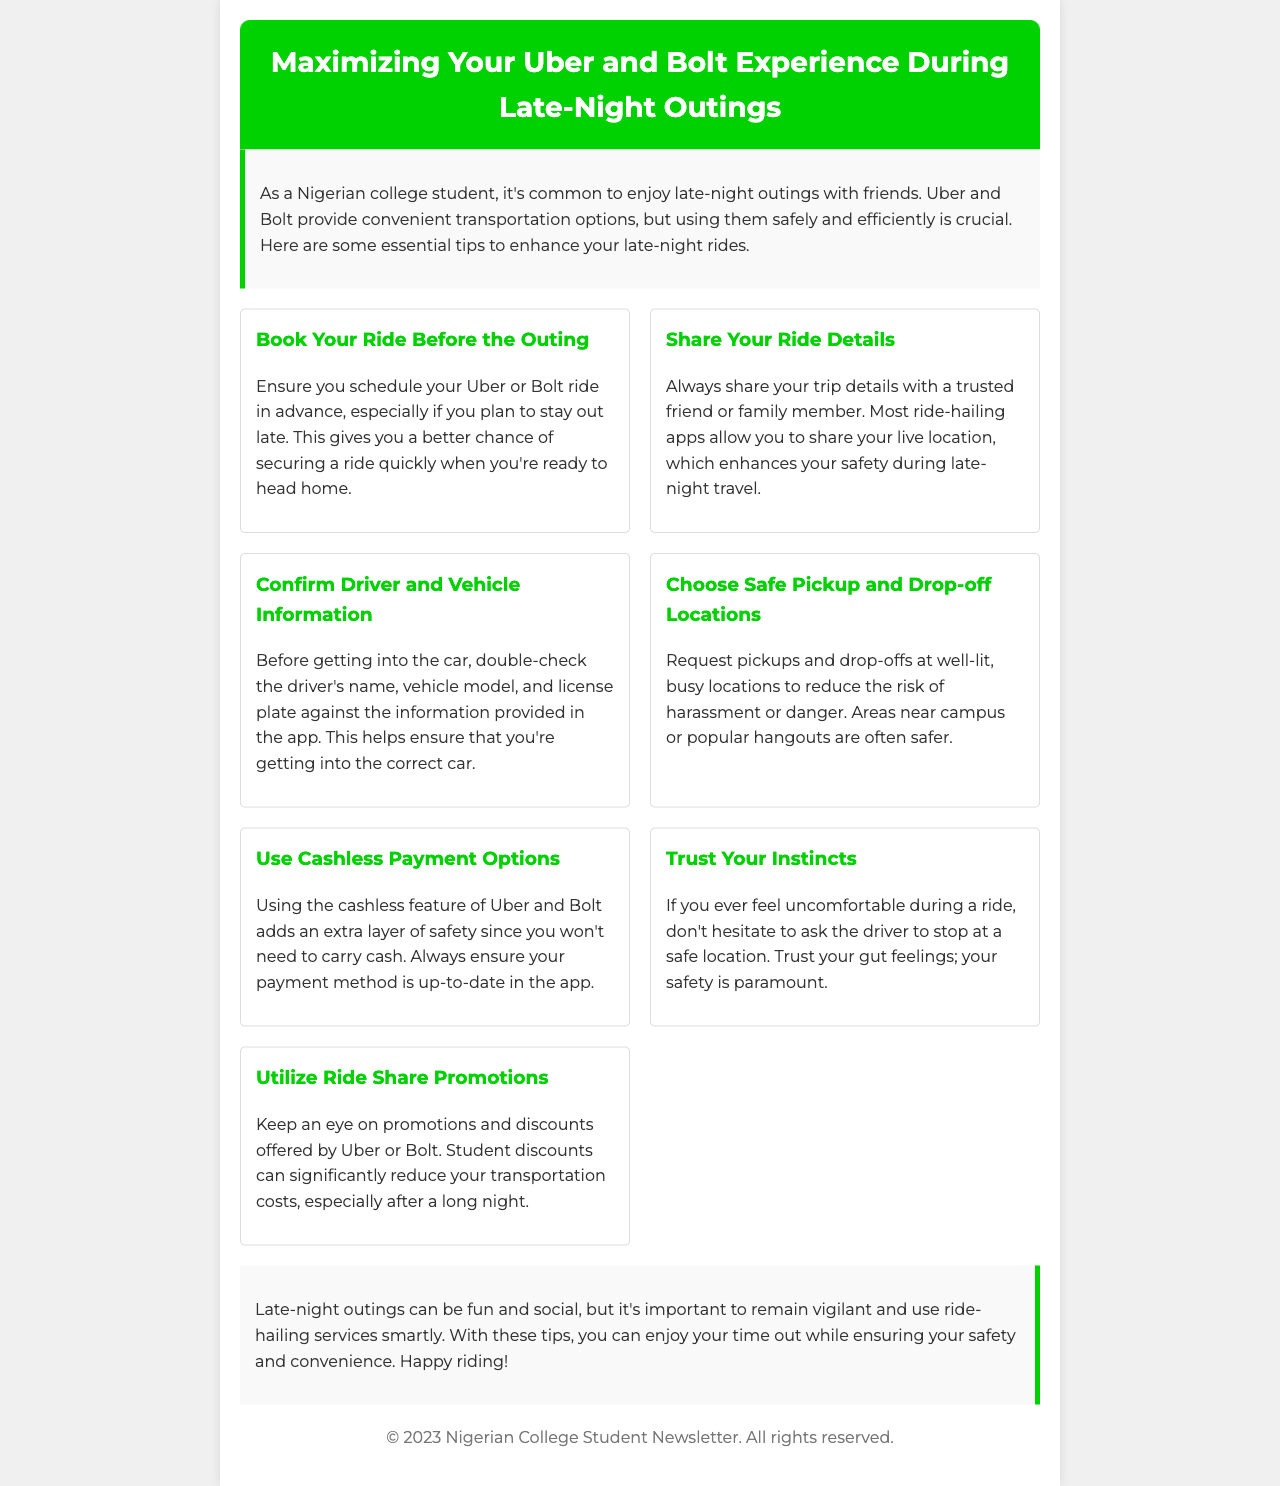What is the title of the newsletter? The title of the newsletter is stated clearly at the beginning.
Answer: Maximizing Your Uber and Bolt Experience During Late-Night Outings How many tips are listed in the document? The document states the number of tips offered in the tips section.
Answer: Seven What should you do before getting into the car? The document advises confirming specific information before entering the vehicle.
Answer: Confirm driver and vehicle information What payment option does the document suggest for added safety? The document specifies a payment method that enhances security while using ride-hailing.
Answer: Cashless payment options Where should you request pickups and drop-offs? The document suggests certain types of locations for safety during rides.
Answer: Well-lit, busy locations What is one piece of advice regarding sharing ride details? The document recommends sharing ride information with someone trusted for safety.
Answer: Share your ride details What are students encouraged to look for to reduce transportation costs? The document mentions a specific type of offer available through the apps.
Answer: Ride Share Promotions 